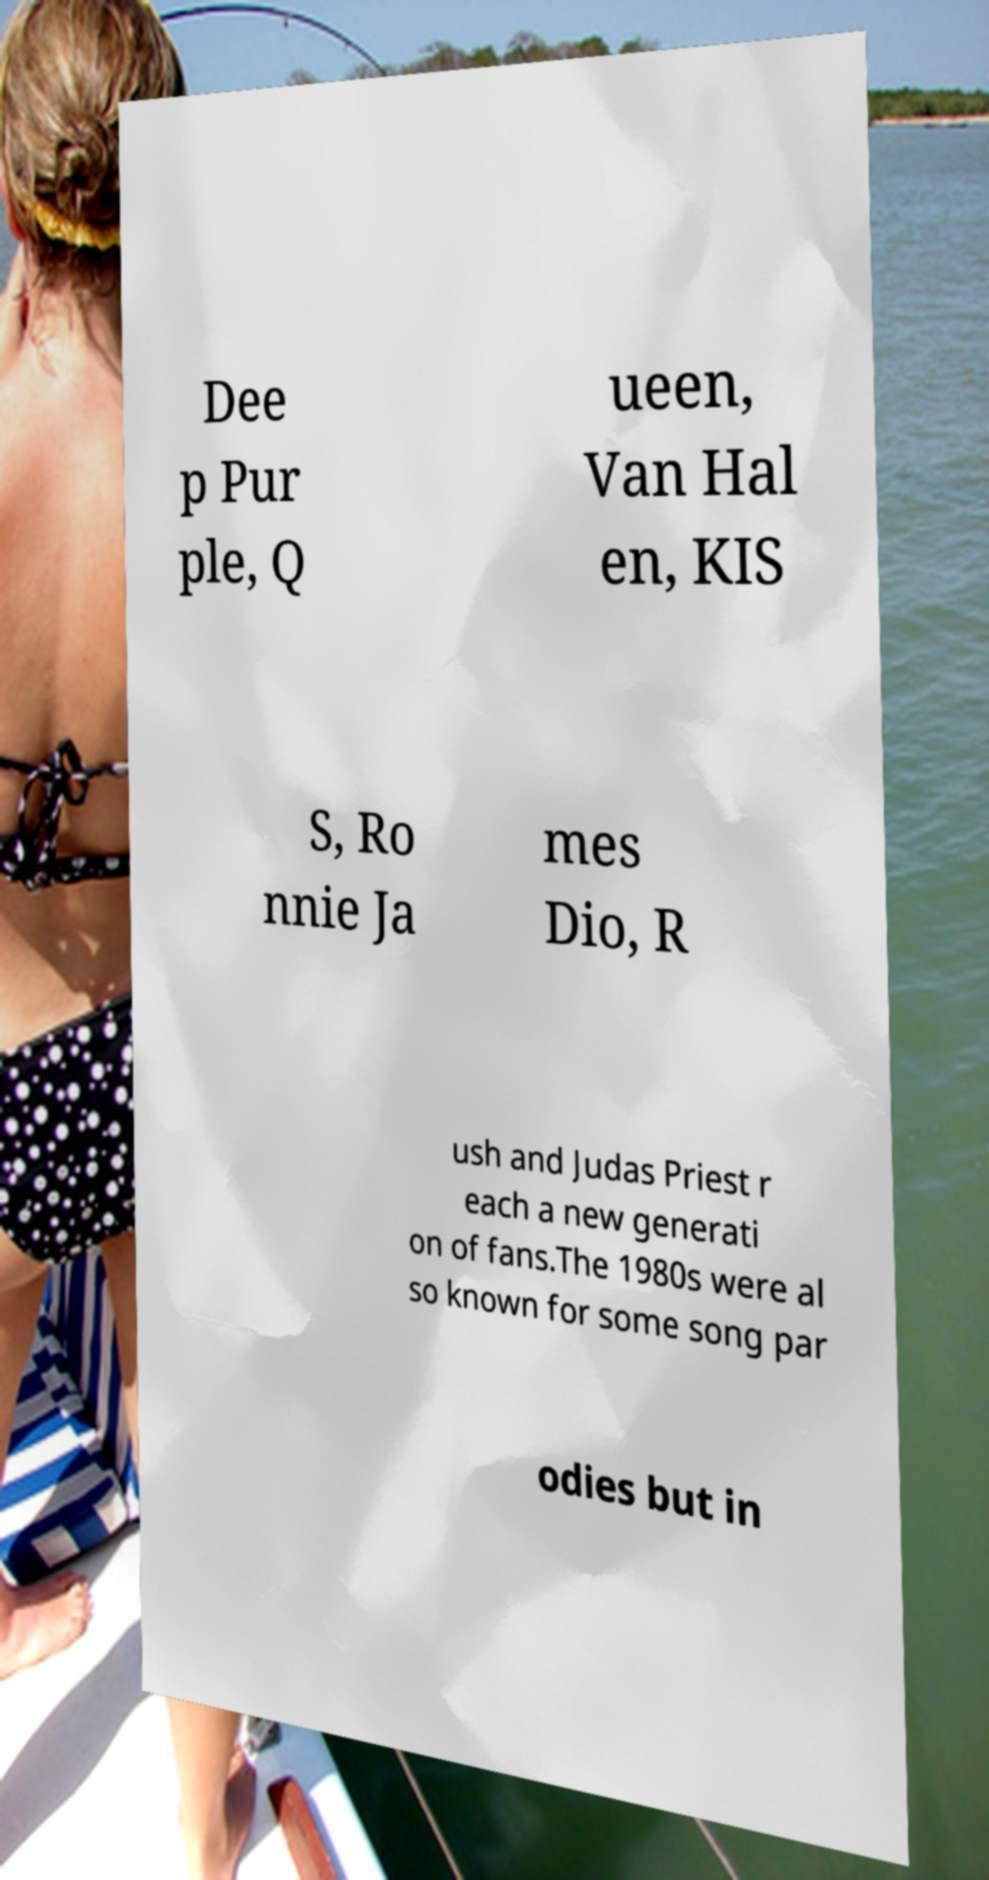Could you extract and type out the text from this image? Dee p Pur ple, Q ueen, Van Hal en, KIS S, Ro nnie Ja mes Dio, R ush and Judas Priest r each a new generati on of fans.The 1980s were al so known for some song par odies but in 